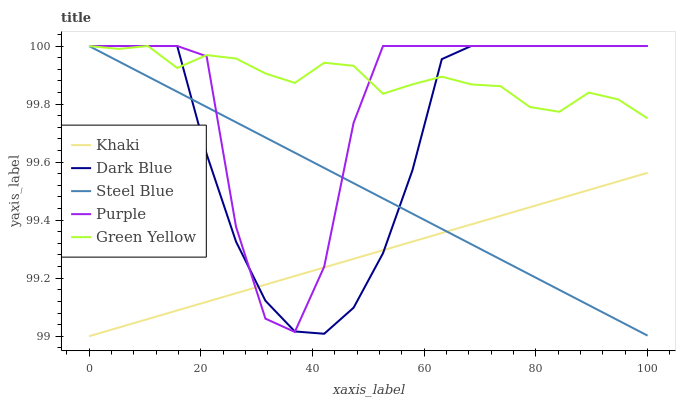Does Khaki have the minimum area under the curve?
Answer yes or no. Yes. Does Green Yellow have the maximum area under the curve?
Answer yes or no. Yes. Does Dark Blue have the minimum area under the curve?
Answer yes or no. No. Does Dark Blue have the maximum area under the curve?
Answer yes or no. No. Is Steel Blue the smoothest?
Answer yes or no. Yes. Is Purple the roughest?
Answer yes or no. Yes. Is Dark Blue the smoothest?
Answer yes or no. No. Is Dark Blue the roughest?
Answer yes or no. No. Does Khaki have the lowest value?
Answer yes or no. Yes. Does Dark Blue have the lowest value?
Answer yes or no. No. Does Steel Blue have the highest value?
Answer yes or no. Yes. Does Khaki have the highest value?
Answer yes or no. No. Is Khaki less than Green Yellow?
Answer yes or no. Yes. Is Green Yellow greater than Khaki?
Answer yes or no. Yes. Does Dark Blue intersect Khaki?
Answer yes or no. Yes. Is Dark Blue less than Khaki?
Answer yes or no. No. Is Dark Blue greater than Khaki?
Answer yes or no. No. Does Khaki intersect Green Yellow?
Answer yes or no. No. 